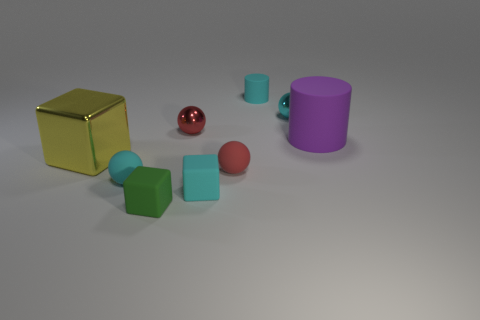Subtract all large yellow shiny blocks. How many blocks are left? 2 Add 1 small things. How many objects exist? 10 Subtract all red cylinders. How many red balls are left? 2 Subtract all cyan cylinders. How many cylinders are left? 1 Subtract all blocks. How many objects are left? 6 Add 8 yellow shiny objects. How many yellow shiny objects are left? 9 Add 7 large cubes. How many large cubes exist? 8 Subtract 0 brown cylinders. How many objects are left? 9 Subtract 4 balls. How many balls are left? 0 Subtract all gray blocks. Subtract all brown cylinders. How many blocks are left? 3 